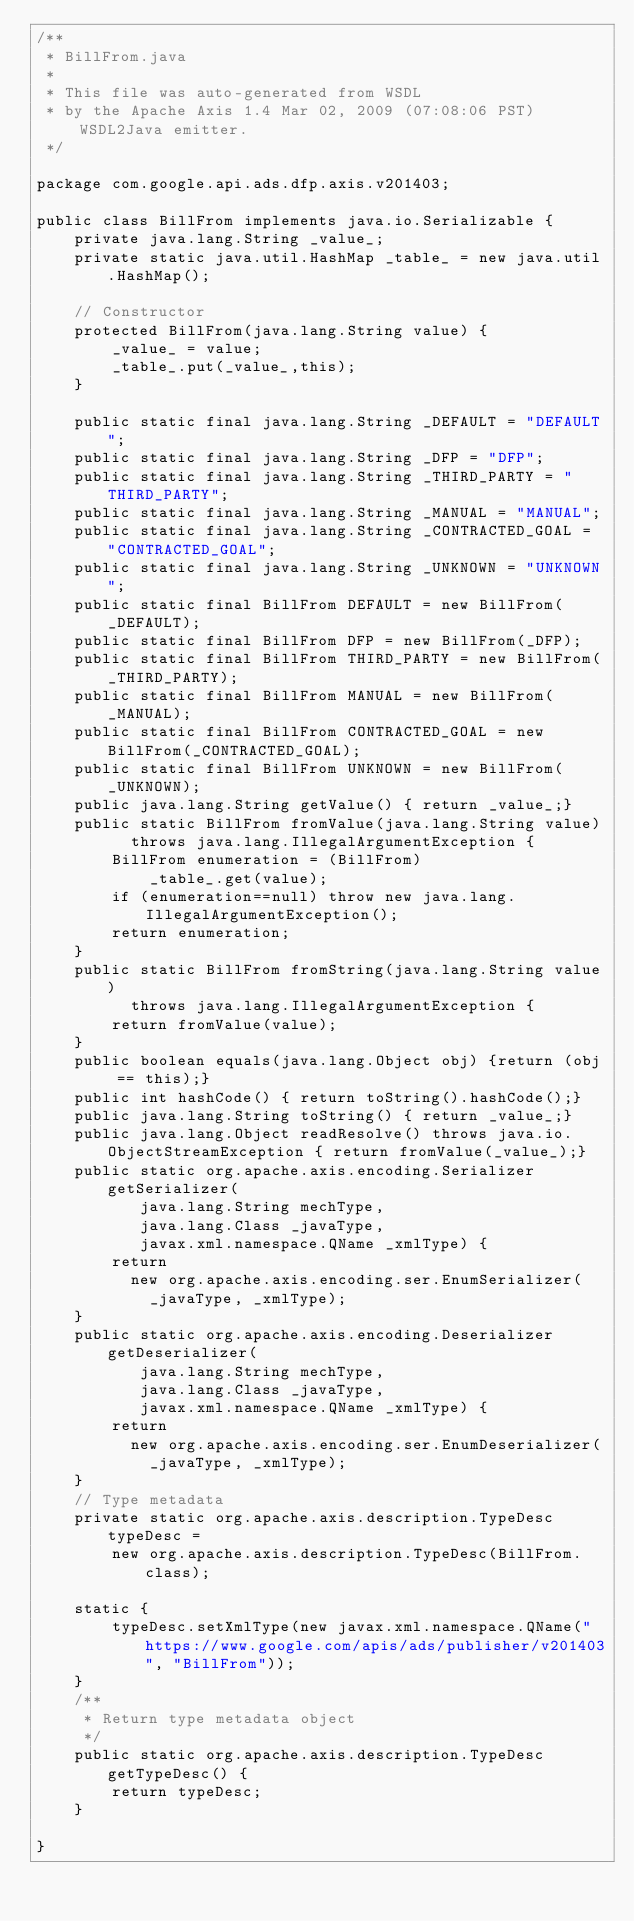Convert code to text. <code><loc_0><loc_0><loc_500><loc_500><_Java_>/**
 * BillFrom.java
 *
 * This file was auto-generated from WSDL
 * by the Apache Axis 1.4 Mar 02, 2009 (07:08:06 PST) WSDL2Java emitter.
 */

package com.google.api.ads.dfp.axis.v201403;

public class BillFrom implements java.io.Serializable {
    private java.lang.String _value_;
    private static java.util.HashMap _table_ = new java.util.HashMap();

    // Constructor
    protected BillFrom(java.lang.String value) {
        _value_ = value;
        _table_.put(_value_,this);
    }

    public static final java.lang.String _DEFAULT = "DEFAULT";
    public static final java.lang.String _DFP = "DFP";
    public static final java.lang.String _THIRD_PARTY = "THIRD_PARTY";
    public static final java.lang.String _MANUAL = "MANUAL";
    public static final java.lang.String _CONTRACTED_GOAL = "CONTRACTED_GOAL";
    public static final java.lang.String _UNKNOWN = "UNKNOWN";
    public static final BillFrom DEFAULT = new BillFrom(_DEFAULT);
    public static final BillFrom DFP = new BillFrom(_DFP);
    public static final BillFrom THIRD_PARTY = new BillFrom(_THIRD_PARTY);
    public static final BillFrom MANUAL = new BillFrom(_MANUAL);
    public static final BillFrom CONTRACTED_GOAL = new BillFrom(_CONTRACTED_GOAL);
    public static final BillFrom UNKNOWN = new BillFrom(_UNKNOWN);
    public java.lang.String getValue() { return _value_;}
    public static BillFrom fromValue(java.lang.String value)
          throws java.lang.IllegalArgumentException {
        BillFrom enumeration = (BillFrom)
            _table_.get(value);
        if (enumeration==null) throw new java.lang.IllegalArgumentException();
        return enumeration;
    }
    public static BillFrom fromString(java.lang.String value)
          throws java.lang.IllegalArgumentException {
        return fromValue(value);
    }
    public boolean equals(java.lang.Object obj) {return (obj == this);}
    public int hashCode() { return toString().hashCode();}
    public java.lang.String toString() { return _value_;}
    public java.lang.Object readResolve() throws java.io.ObjectStreamException { return fromValue(_value_);}
    public static org.apache.axis.encoding.Serializer getSerializer(
           java.lang.String mechType, 
           java.lang.Class _javaType,  
           javax.xml.namespace.QName _xmlType) {
        return 
          new org.apache.axis.encoding.ser.EnumSerializer(
            _javaType, _xmlType);
    }
    public static org.apache.axis.encoding.Deserializer getDeserializer(
           java.lang.String mechType, 
           java.lang.Class _javaType,  
           javax.xml.namespace.QName _xmlType) {
        return 
          new org.apache.axis.encoding.ser.EnumDeserializer(
            _javaType, _xmlType);
    }
    // Type metadata
    private static org.apache.axis.description.TypeDesc typeDesc =
        new org.apache.axis.description.TypeDesc(BillFrom.class);

    static {
        typeDesc.setXmlType(new javax.xml.namespace.QName("https://www.google.com/apis/ads/publisher/v201403", "BillFrom"));
    }
    /**
     * Return type metadata object
     */
    public static org.apache.axis.description.TypeDesc getTypeDesc() {
        return typeDesc;
    }

}
</code> 